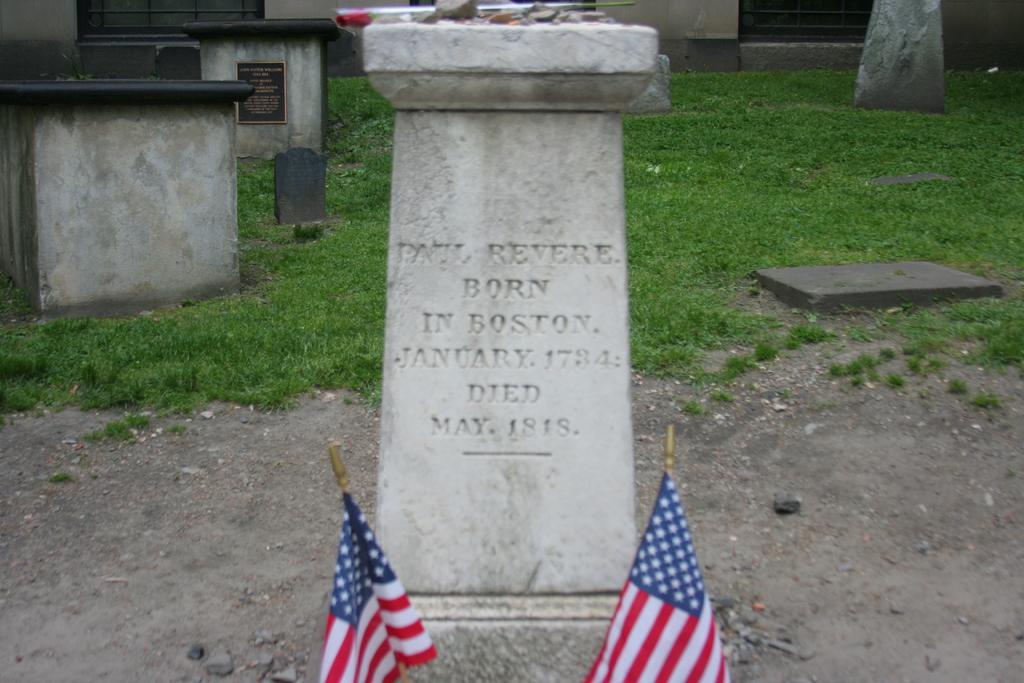Please provide a concise description of this image. In this picture I can observe gravestone in the middle of the picture. In the background I can observe some grass on the ground. 